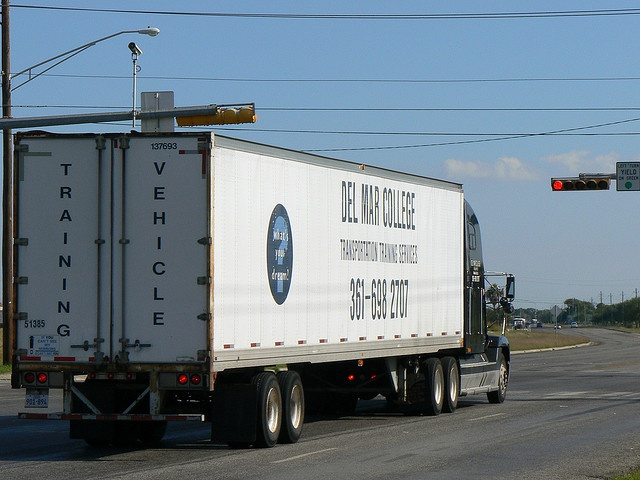Describe the objects in this image and their specific colors. I can see truck in lightblue, gray, black, lightgray, and darkgray tones, traffic light in lightblue, maroon, black, olive, and gray tones, and traffic light in lightblue, black, gray, red, and maroon tones in this image. 